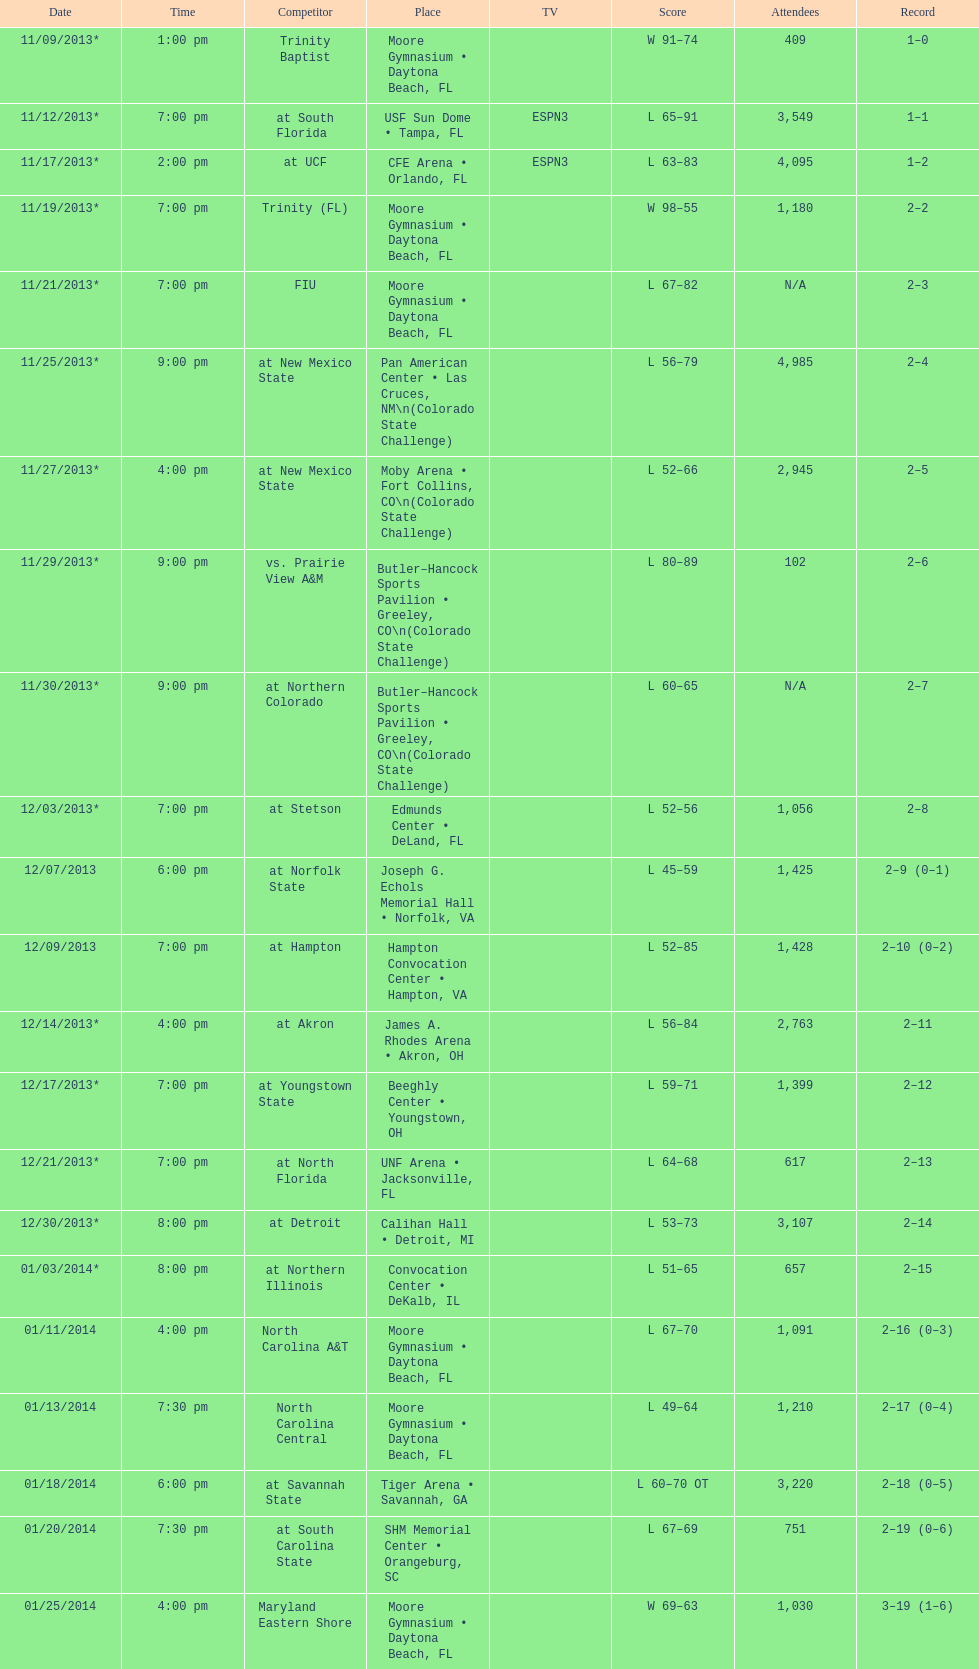Which game was later at night, fiu or northern colorado? Northern Colorado. 